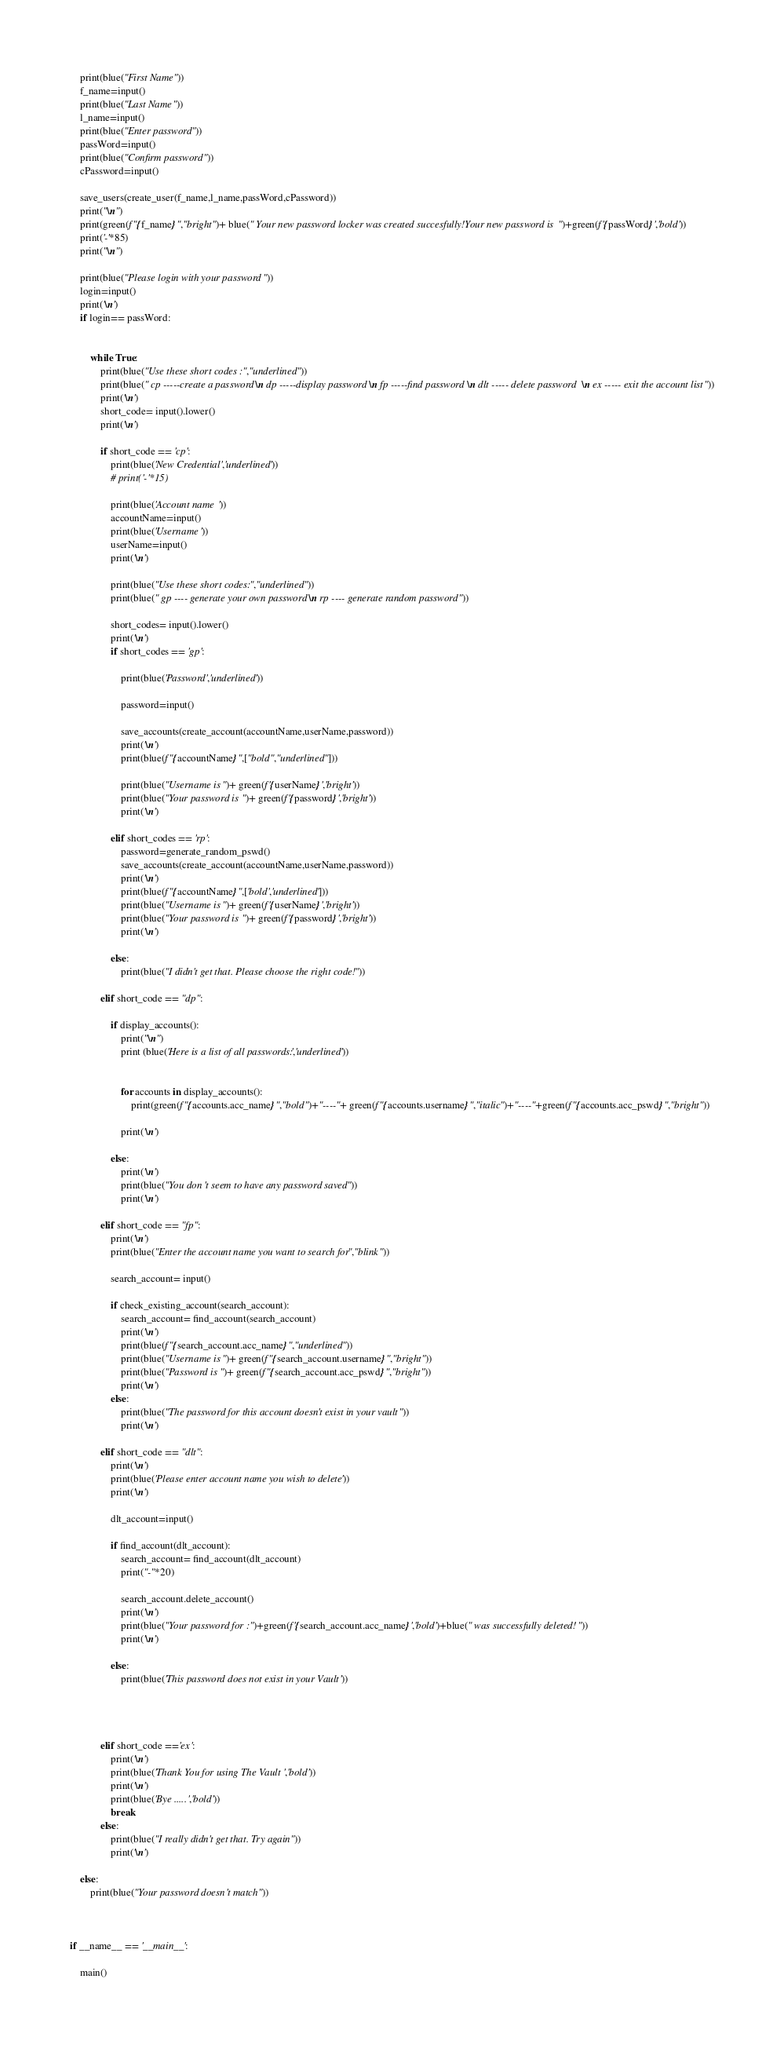Convert code to text. <code><loc_0><loc_0><loc_500><loc_500><_Python_>    print(blue("First Name"))
    f_name=input()
    print(blue("Last Name"))
    l_name=input()
    print(blue("Enter password"))
    passWord=input()
    print(blue("Confirm password"))
    cPassword=input()

    save_users(create_user(f_name,l_name,passWord,cPassword))
    print("\n")
    print(green(f"{f_name}","bright")+ blue(" Your new password locker was created succesfully!Your new password is ")+green(f'{passWord}','bold'))
    print('-'*85)
    print("\n")

    print(blue("Please login with your password "))
    login=input()
    print('\n')
    if login== passWord:


        while True:
            print(blue("Use these short codes :","underlined"))
            print(blue(" cp -----create a password \n dp -----display password \n fp -----find password \n dlt ----- delete password  \n ex ----- exit the account list"))
            print('\n')
            short_code= input().lower()
            print('\n')

            if short_code == 'cp':
                print(blue('New Credential','underlined'))
                # print('-'*15)

                print(blue('Account name '))
                accountName=input()
                print(blue('Username '))
                userName=input()
                print('\n')
                
                print(blue("Use these short codes:","underlined"))
                print(blue(" gp ---- generate your own password \n rp ---- generate random password "))

                short_codes= input().lower()
                print('\n')
                if short_codes == 'gp':

                    print(blue('Password','underlined'))

                    password=input()

                    save_accounts(create_account(accountName,userName,password))
                    print('\n')
                    print(blue(f"{accountName}",["bold","underlined"]))

                    print(blue("Username is ")+ green(f'{userName}','bright'))
                    print(blue("Your password is ")+ green(f'{password}','bright'))
                    print('\n')
                
                elif short_codes == 'rp':
                    password=generate_random_pswd()
                    save_accounts(create_account(accountName,userName,password))
                    print('\n')
                    print(blue(f"{accountName}",['bold','underlined']))
                    print(blue("Username is ")+ green(f'{userName}','bright'))
                    print(blue("Your password is ")+ green(f'{password}','bright'))
                    print('\n')

                else:
                    print(blue("I didn't get that. Please choose the right code!"))

            elif short_code == "dp":

                if display_accounts():
                    print("\n")
                    print (blue('Here is a list of all passwords:','underlined'))
                    

                    for accounts in display_accounts():
                        print(green(f"{accounts.acc_name}","bold")+"----"+ green(f"{accounts.username}","italic")+"----"+green(f"{accounts.acc_pswd}","bright"))

                    print('\n')

                else:
                    print('\n')
                    print(blue("You don't seem to have any password saved"))
                    print('\n')
        
            elif short_code == "fp":
                print('\n')
                print(blue("Enter the account name you want to search for","blink"))

                search_account= input()

                if check_existing_account(search_account):
                    search_account= find_account(search_account)
                    print('\n')
                    print(blue(f"{search_account.acc_name}","underlined"))
                    print(blue("Username is ")+ green(f"{search_account.username}","bright"))
                    print(blue("Password is ")+ green(f"{search_account.acc_pswd}","bright"))
                    print('\n')
                else:
                    print(blue("The password for this account doesn't exist in your vault"))
                    print('\n')
            
            elif short_code == "dlt":
                print('\n')
                print(blue('Please enter account name you wish to delete'))
                print('\n')

                dlt_account=input()

                if find_account(dlt_account):
                    search_account= find_account(dlt_account)
                    print("-"*20)

                    search_account.delete_account()
                    print('\n')
                    print(blue("Your password for :")+green(f'{search_account.acc_name}','bold')+blue(" was successfully deleted!"))
                    print('\n')
            
                else:
                    print(blue('This password does not exist in your Vault'))
        
        
                
        
            elif short_code =='ex':
                print('\n')
                print(blue('Thank You for using The Vault','bold'))
                print('\n')
                print(blue('Bye .....','bold'))
                break
            else:
                print(blue("I really didn't get that. Try again"))
                print('\n')

    else:
        print(blue("Your password doesn't match"))   



if __name__ == '__main__':

    main()</code> 